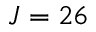<formula> <loc_0><loc_0><loc_500><loc_500>J = 2 6</formula> 